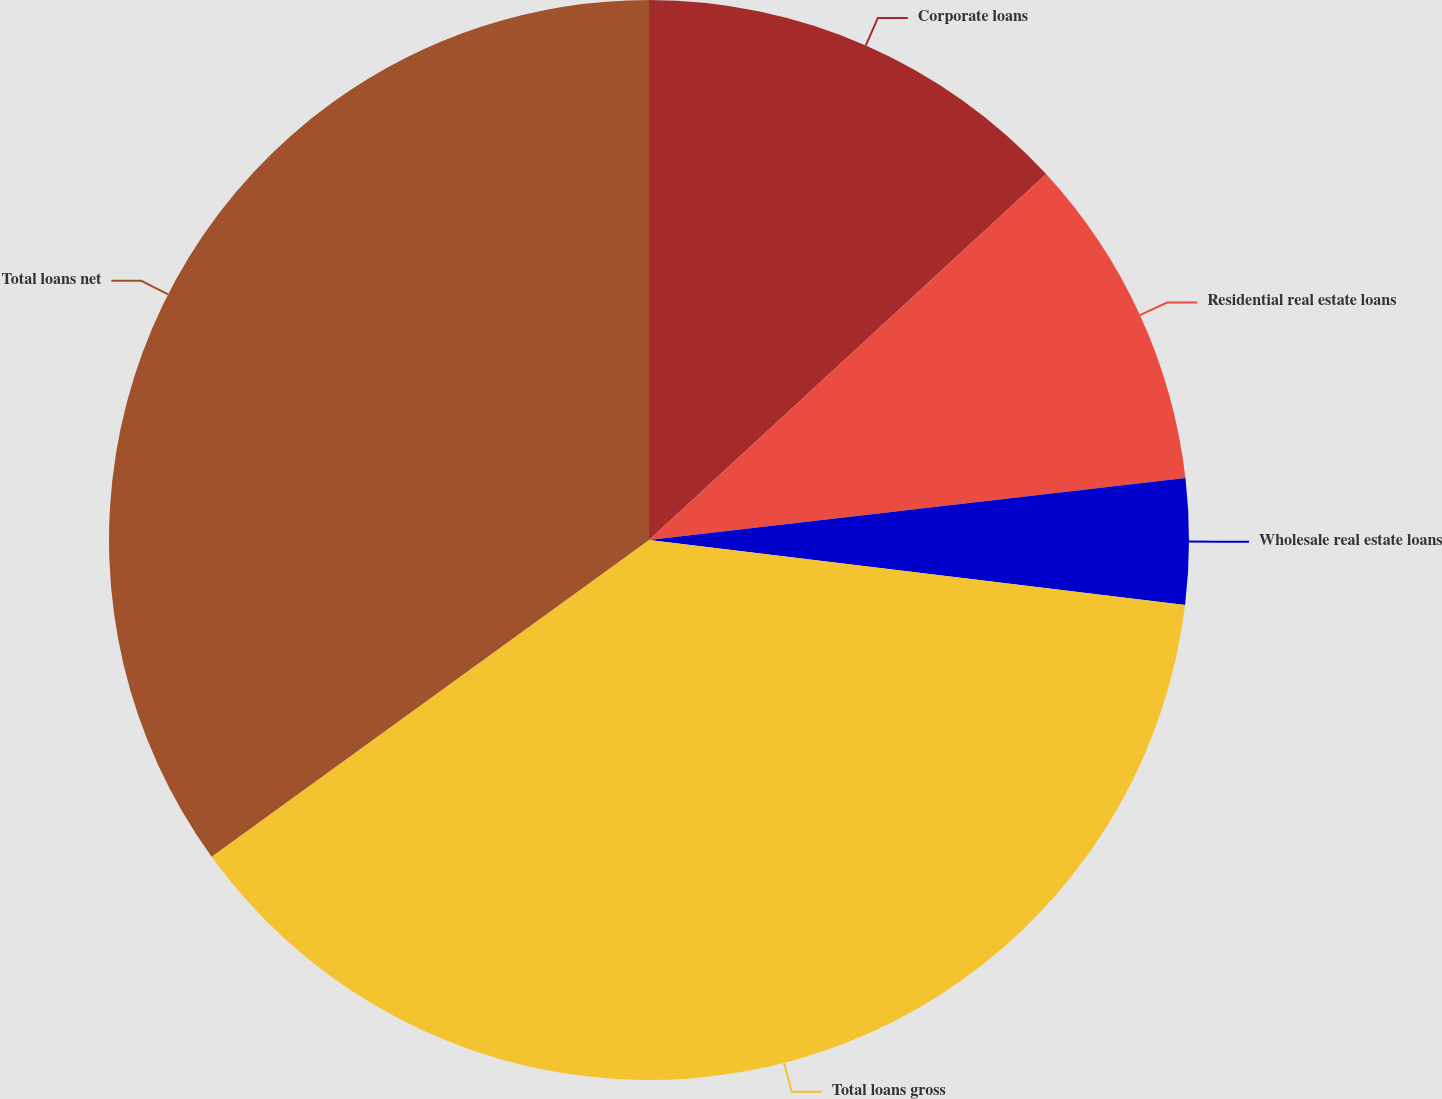Convert chart. <chart><loc_0><loc_0><loc_500><loc_500><pie_chart><fcel>Corporate loans<fcel>Residential real estate loans<fcel>Wholesale real estate loans<fcel>Total loans gross<fcel>Total loans net<nl><fcel>13.15%<fcel>10.02%<fcel>3.75%<fcel>38.1%<fcel>34.97%<nl></chart> 